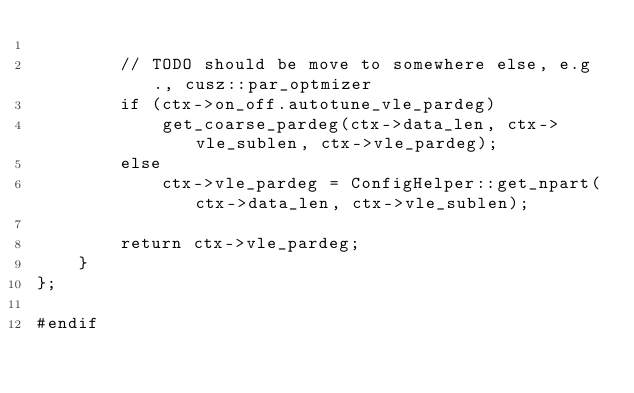<code> <loc_0><loc_0><loc_500><loc_500><_Cuda_>
        // TODO should be move to somewhere else, e.g., cusz::par_optmizer
        if (ctx->on_off.autotune_vle_pardeg)
            get_coarse_pardeg(ctx->data_len, ctx->vle_sublen, ctx->vle_pardeg);
        else
            ctx->vle_pardeg = ConfigHelper::get_npart(ctx->data_len, ctx->vle_sublen);

        return ctx->vle_pardeg;
    }
};

#endif</code> 